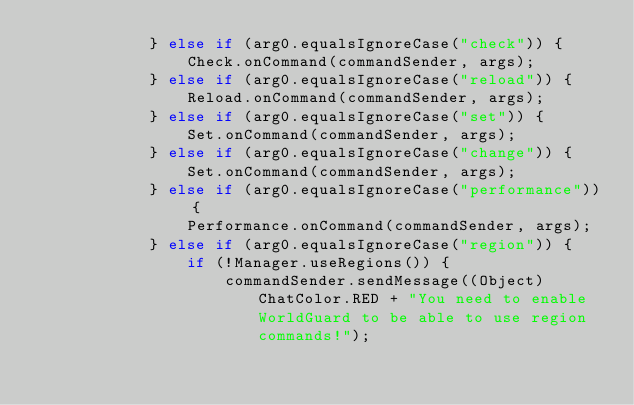Convert code to text. <code><loc_0><loc_0><loc_500><loc_500><_Java_>            } else if (arg0.equalsIgnoreCase("check")) {
                Check.onCommand(commandSender, args);
            } else if (arg0.equalsIgnoreCase("reload")) {
                Reload.onCommand(commandSender, args);
            } else if (arg0.equalsIgnoreCase("set")) {
                Set.onCommand(commandSender, args);
            } else if (arg0.equalsIgnoreCase("change")) {
                Set.onCommand(commandSender, args);
            } else if (arg0.equalsIgnoreCase("performance")) {
                Performance.onCommand(commandSender, args);
            } else if (arg0.equalsIgnoreCase("region")) {
                if (!Manager.useRegions()) {
                    commandSender.sendMessage((Object)ChatColor.RED + "You need to enable WorldGuard to be able to use region commands!");</code> 